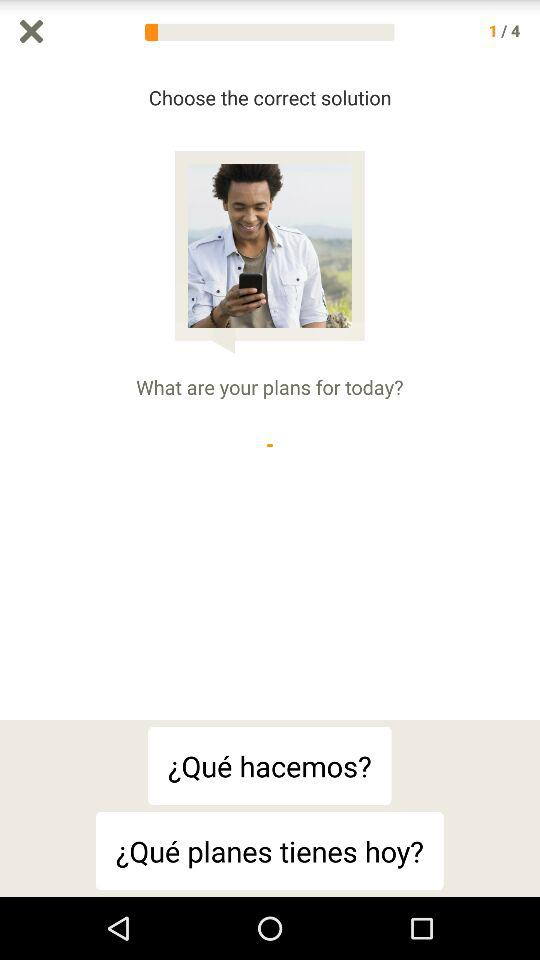How many total questions are there? There are 4 questions. 